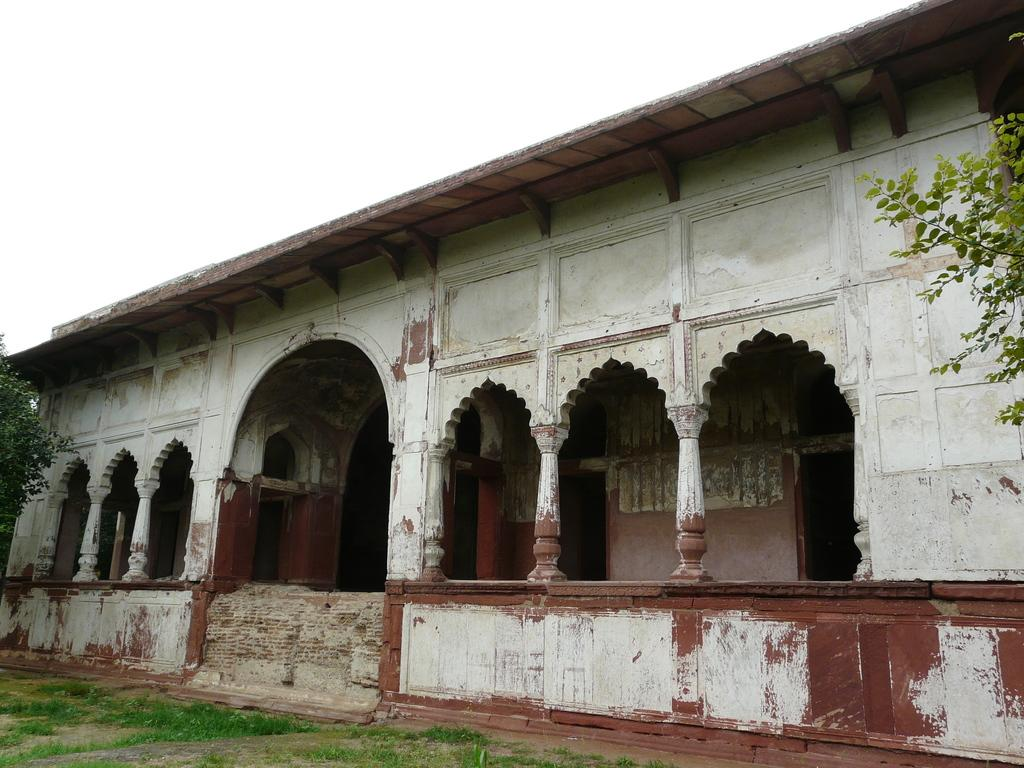What type of structure is present in the image? There is a building in the image. What can be seen on both sides of the image? There are trees on both the right and left sides of the image. What type of vegetation is at the bottom of the image? There is grass at the bottom of the image. What is visible at the top of the image? The sky is visible at the top of the image. What type of cork can be seen floating in the sky in the image? There is no cork present in the image, and the sky is not depicted as containing any floating objects. 